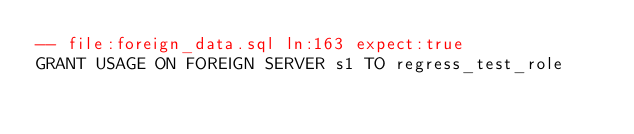Convert code to text. <code><loc_0><loc_0><loc_500><loc_500><_SQL_>-- file:foreign_data.sql ln:163 expect:true
GRANT USAGE ON FOREIGN SERVER s1 TO regress_test_role
</code> 